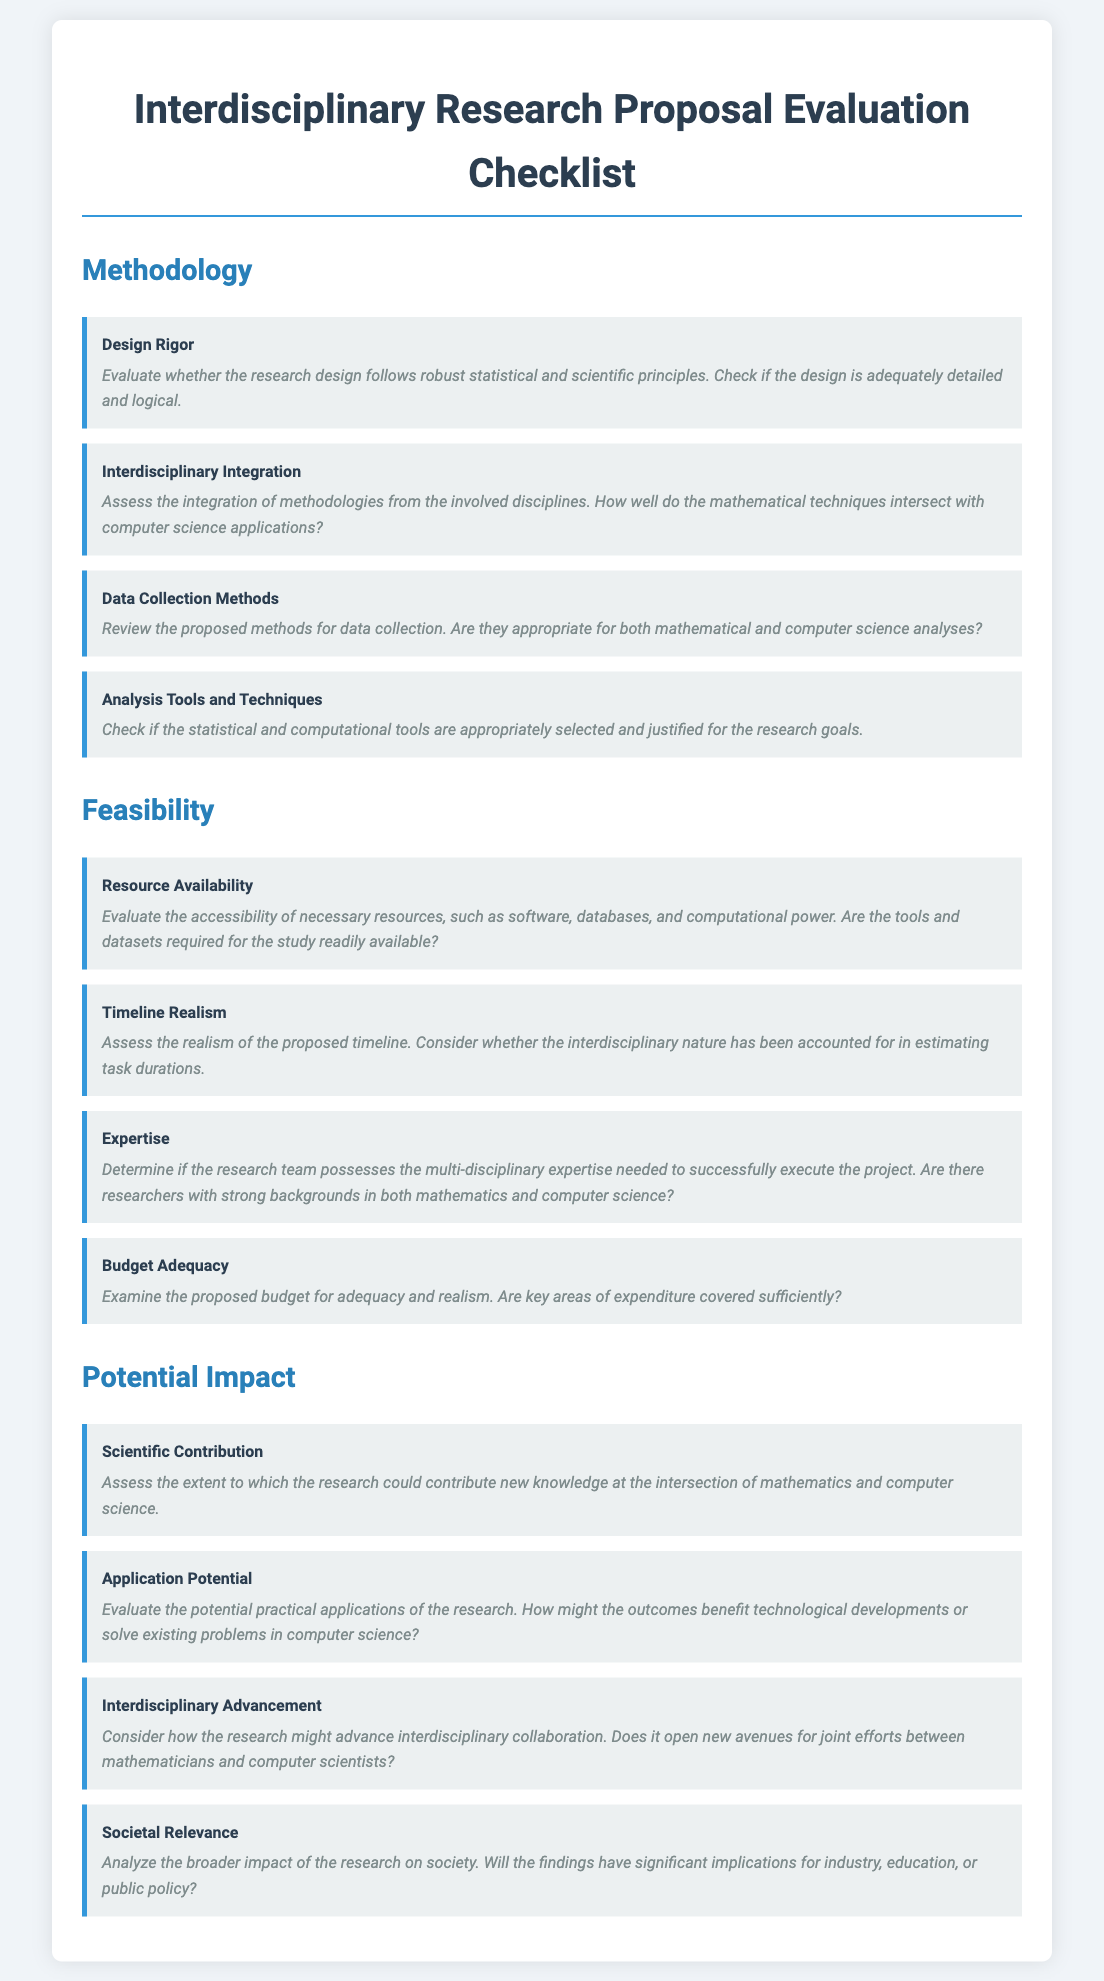What is the title of the document? The title is indicated at the top of the document as "Interdisciplinary Research Proposal Evaluation Checklist."
Answer: Interdisciplinary Research Proposal Evaluation Checklist How many sections are in the checklist? There are three main sections clearly labeled: Methodology, Feasibility, and Potential Impact.
Answer: three What does "Design Rigor" evaluate? The criterion "Design Rigor" evaluates whether the research design follows robust statistical and scientific principles.
Answer: robust statistical and scientific principles What is evaluated under "Application Potential"? The criterion "Application Potential" evaluates the potential practical applications of the research.
Answer: potential practical applications Which criterion assesses the accessibility of necessary resources? The criterion that assesses resource accessibility is "Resource Availability."
Answer: Resource Availability What does the "Budget Adequacy" criterion examine? "Budget Adequacy" examines the proposed budget for adequacy and realism.
Answer: adequacy and realism How many criteria are listed under "Feasibility"? There are four criteria listed under the "Feasibility" section.
Answer: four What is the main focus of "Scientific Contribution"? "Scientific Contribution" focuses on the extent of new knowledge contribution at the intersection of mathematics and computer science.
Answer: new knowledge contribution Which section of the checklist includes "Interdisciplinary Advancement"? "Interdisciplinary Advancement" is found in the "Potential Impact" section of the checklist.
Answer: Potential Impact What aspect does "Societal Relevance" analyze? "Societal Relevance" analyzes the broader impact of the research on society.
Answer: broader impact of the research on society 